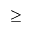Convert formula to latex. <formula><loc_0><loc_0><loc_500><loc_500>\geq</formula> 